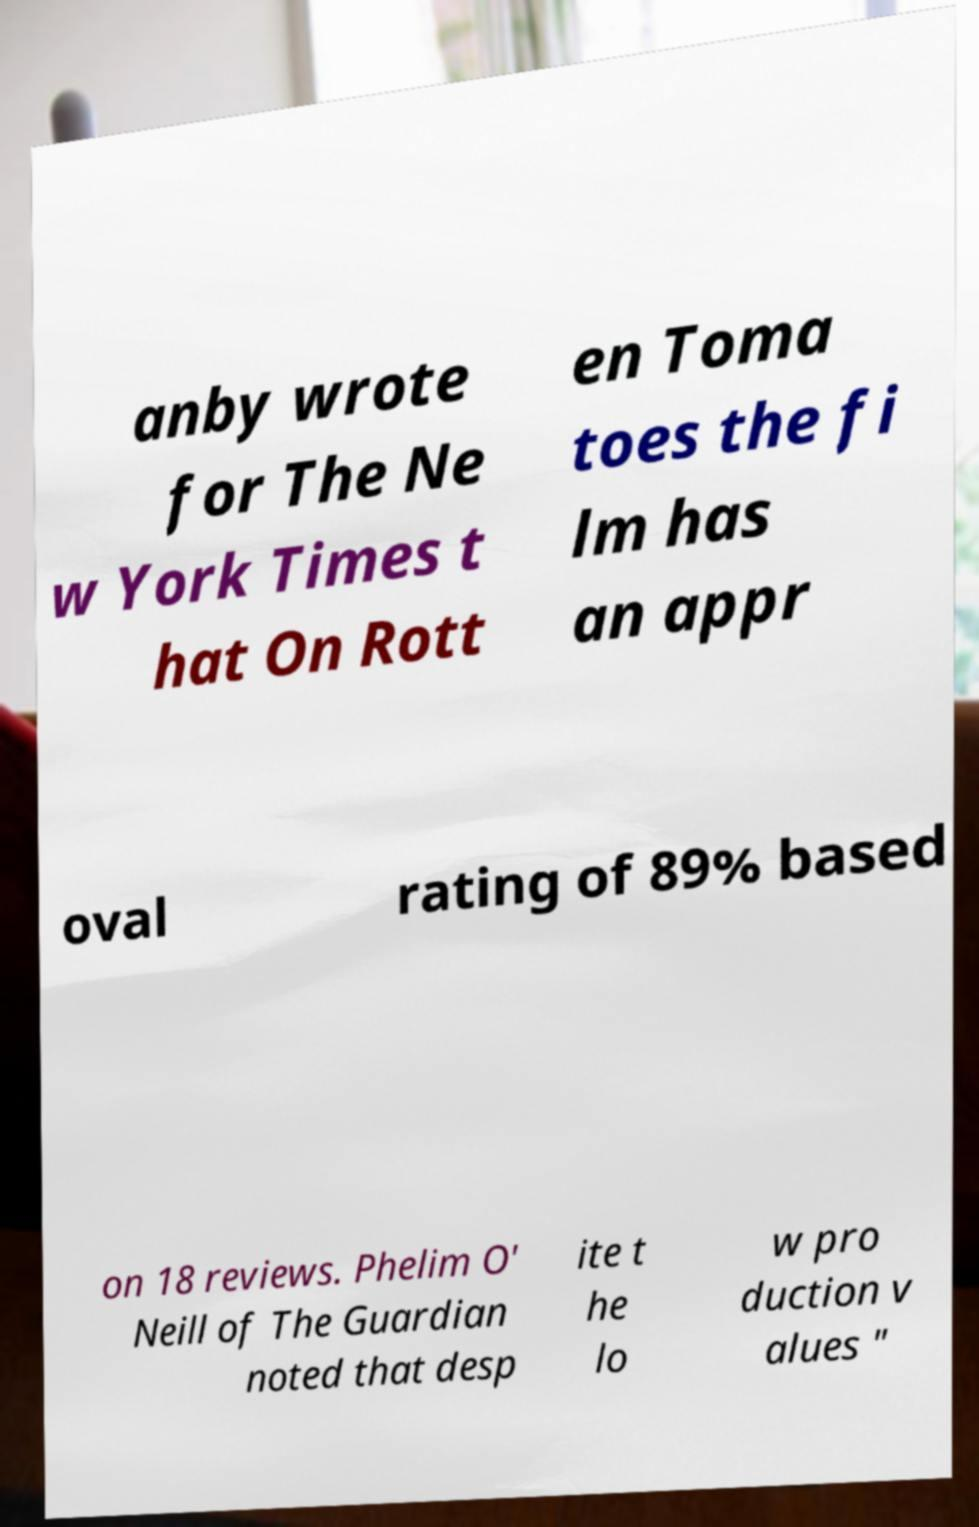Please read and relay the text visible in this image. What does it say? anby wrote for The Ne w York Times t hat On Rott en Toma toes the fi lm has an appr oval rating of 89% based on 18 reviews. Phelim O' Neill of The Guardian noted that desp ite t he lo w pro duction v alues " 